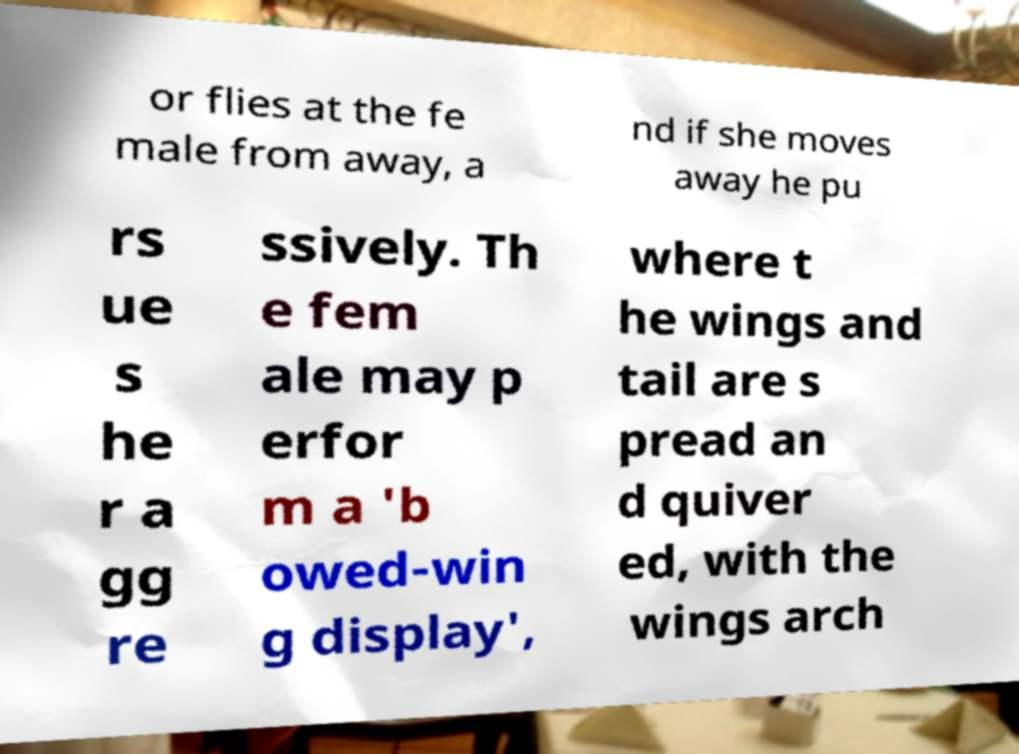Could you extract and type out the text from this image? or flies at the fe male from away, a nd if she moves away he pu rs ue s he r a gg re ssively. Th e fem ale may p erfor m a 'b owed-win g display', where t he wings and tail are s pread an d quiver ed, with the wings arch 